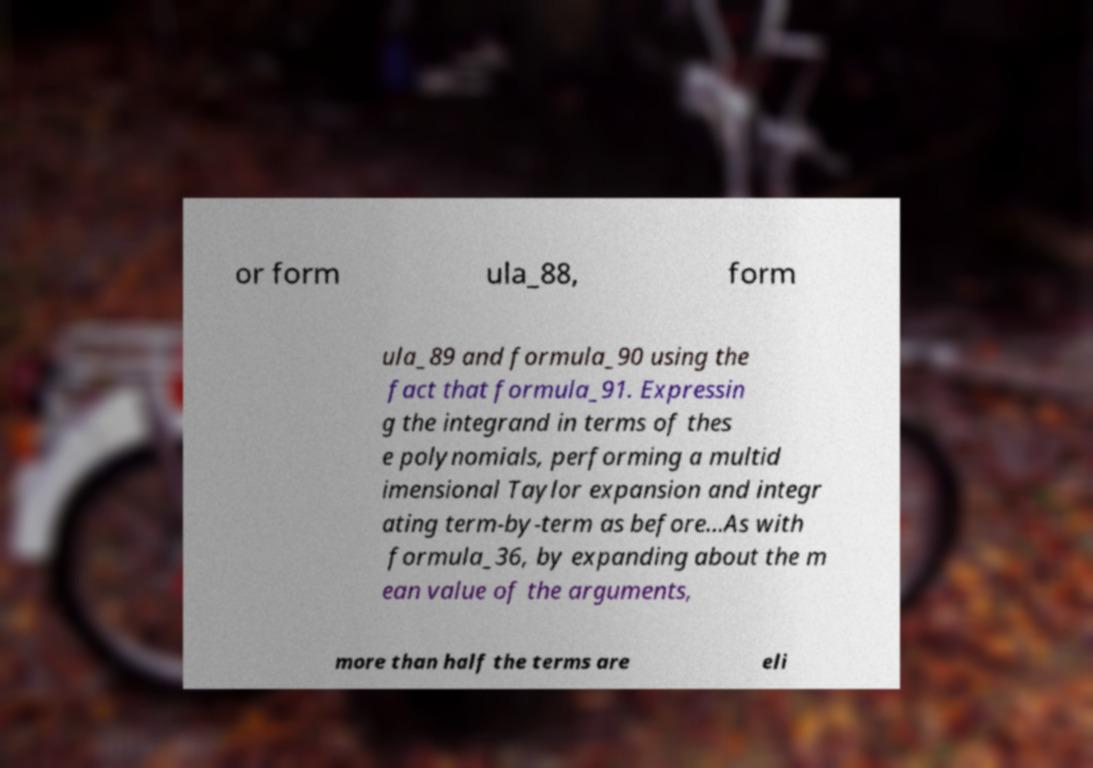Could you extract and type out the text from this image? or form ula_88, form ula_89 and formula_90 using the fact that formula_91. Expressin g the integrand in terms of thes e polynomials, performing a multid imensional Taylor expansion and integr ating term-by-term as before...As with formula_36, by expanding about the m ean value of the arguments, more than half the terms are eli 